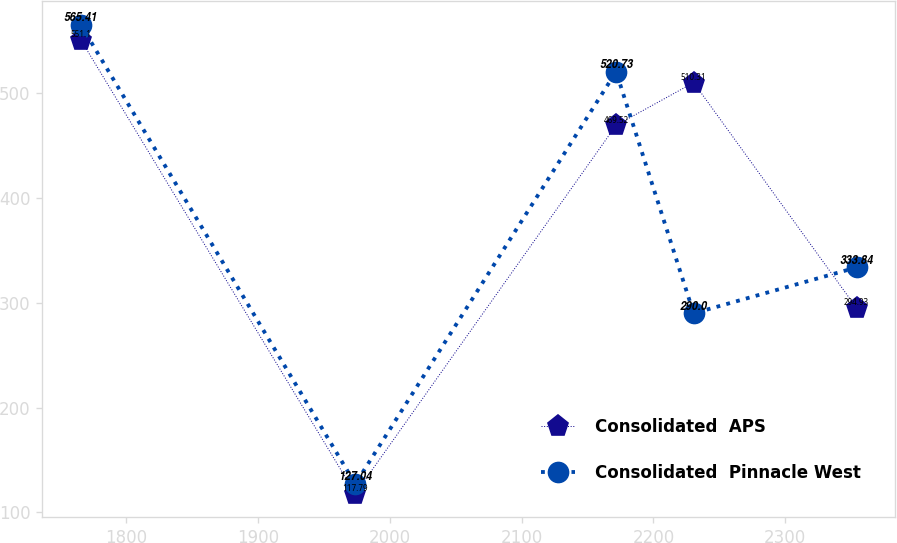Convert chart. <chart><loc_0><loc_0><loc_500><loc_500><line_chart><ecel><fcel>Consolidated  APS<fcel>Consolidated  Pinnacle West<nl><fcel>1765.66<fcel>551.1<fcel>565.41<nl><fcel>1973.86<fcel>117.79<fcel>127.04<nl><fcel>2171.68<fcel>469.52<fcel>520.73<nl><fcel>2230.53<fcel>510.31<fcel>290<nl><fcel>2354.17<fcel>294.93<fcel>333.84<nl></chart> 